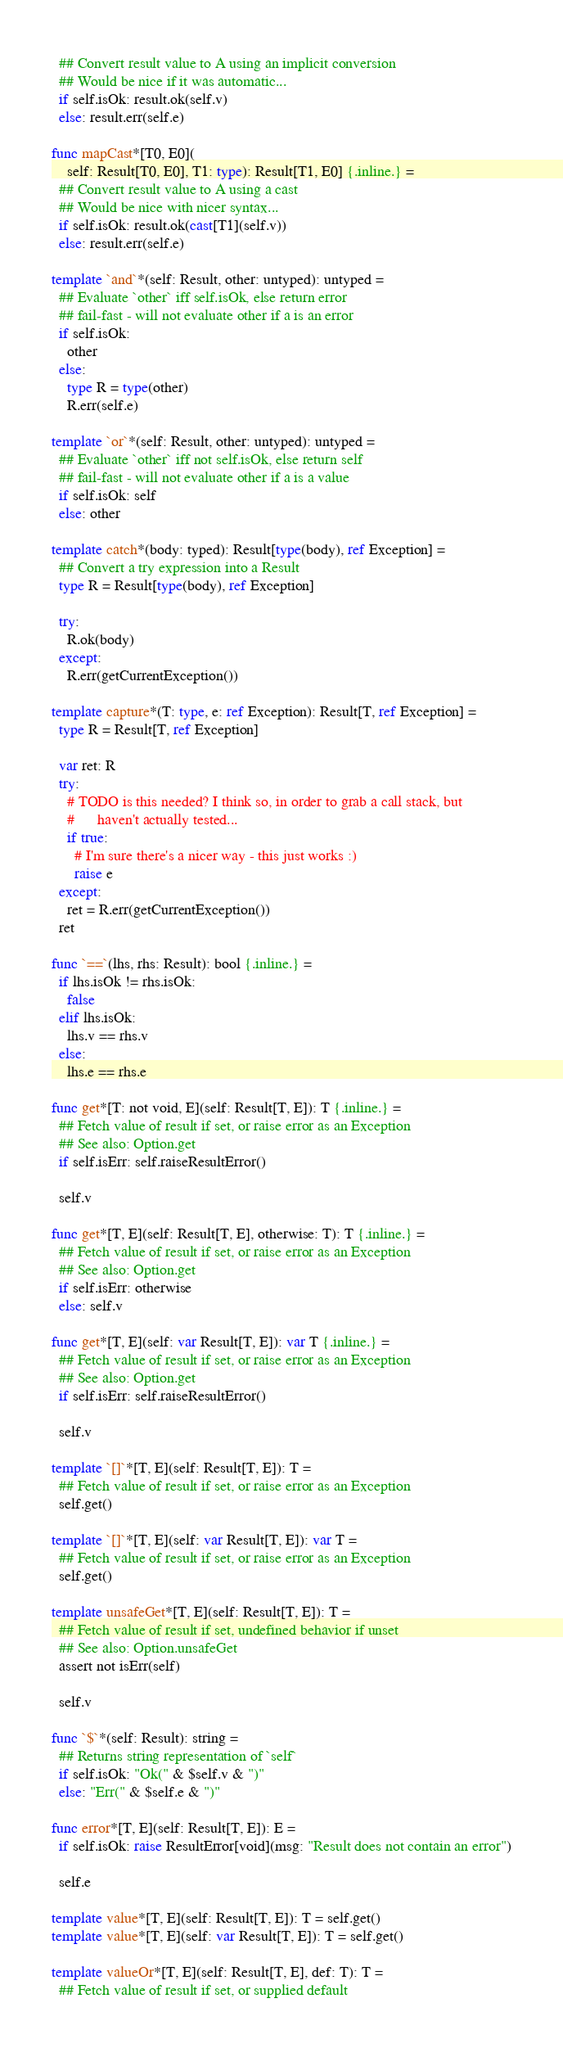<code> <loc_0><loc_0><loc_500><loc_500><_Nim_>  ## Convert result value to A using an implicit conversion
  ## Would be nice if it was automatic...
  if self.isOk: result.ok(self.v)
  else: result.err(self.e)

func mapCast*[T0, E0](
    self: Result[T0, E0], T1: type): Result[T1, E0] {.inline.} =
  ## Convert result value to A using a cast
  ## Would be nice with nicer syntax...
  if self.isOk: result.ok(cast[T1](self.v))
  else: result.err(self.e)

template `and`*(self: Result, other: untyped): untyped =
  ## Evaluate `other` iff self.isOk, else return error
  ## fail-fast - will not evaluate other if a is an error
  if self.isOk:
    other
  else:
    type R = type(other)
    R.err(self.e)

template `or`*(self: Result, other: untyped): untyped =
  ## Evaluate `other` iff not self.isOk, else return self
  ## fail-fast - will not evaluate other if a is a value
  if self.isOk: self
  else: other

template catch*(body: typed): Result[type(body), ref Exception] =
  ## Convert a try expression into a Result
  type R = Result[type(body), ref Exception]

  try:
    R.ok(body)
  except:
    R.err(getCurrentException())

template capture*(T: type, e: ref Exception): Result[T, ref Exception] =
  type R = Result[T, ref Exception]

  var ret: R
  try:
    # TODO is this needed? I think so, in order to grab a call stack, but
    #      haven't actually tested...
    if true:
      # I'm sure there's a nicer way - this just works :)
      raise e
  except:
    ret = R.err(getCurrentException())
  ret

func `==`(lhs, rhs: Result): bool {.inline.} =
  if lhs.isOk != rhs.isOk:
    false
  elif lhs.isOk:
    lhs.v == rhs.v
  else:
    lhs.e == rhs.e

func get*[T: not void, E](self: Result[T, E]): T {.inline.} =
  ## Fetch value of result if set, or raise error as an Exception
  ## See also: Option.get
  if self.isErr: self.raiseResultError()

  self.v

func get*[T, E](self: Result[T, E], otherwise: T): T {.inline.} =
  ## Fetch value of result if set, or raise error as an Exception
  ## See also: Option.get
  if self.isErr: otherwise
  else: self.v

func get*[T, E](self: var Result[T, E]): var T {.inline.} =
  ## Fetch value of result if set, or raise error as an Exception
  ## See also: Option.get
  if self.isErr: self.raiseResultError()

  self.v

template `[]`*[T, E](self: Result[T, E]): T =
  ## Fetch value of result if set, or raise error as an Exception
  self.get()

template `[]`*[T, E](self: var Result[T, E]): var T =
  ## Fetch value of result if set, or raise error as an Exception
  self.get()

template unsafeGet*[T, E](self: Result[T, E]): T =
  ## Fetch value of result if set, undefined behavior if unset
  ## See also: Option.unsafeGet
  assert not isErr(self)

  self.v

func `$`*(self: Result): string =
  ## Returns string representation of `self`
  if self.isOk: "Ok(" & $self.v & ")"
  else: "Err(" & $self.e & ")"

func error*[T, E](self: Result[T, E]): E =
  if self.isOk: raise ResultError[void](msg: "Result does not contain an error")

  self.e

template value*[T, E](self: Result[T, E]): T = self.get()
template value*[T, E](self: var Result[T, E]): T = self.get()

template valueOr*[T, E](self: Result[T, E], def: T): T =
  ## Fetch value of result if set, or supplied default</code> 